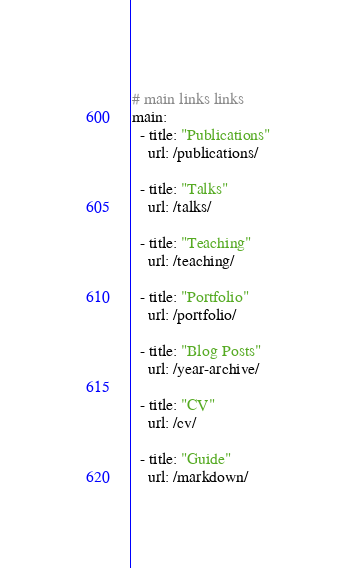Convert code to text. <code><loc_0><loc_0><loc_500><loc_500><_YAML_># main links links
main:
  - title: "Publications"
    url: /publications/

  - title: "Talks"
    url: /talks/

  - title: "Teaching"
    url: /teaching/

  - title: "Portfolio"
    url: /portfolio/

  - title: "Blog Posts"
    url: /year-archive/

  - title: "CV"
    url: /cv/

  - title: "Guide"
    url: /markdown/
</code> 